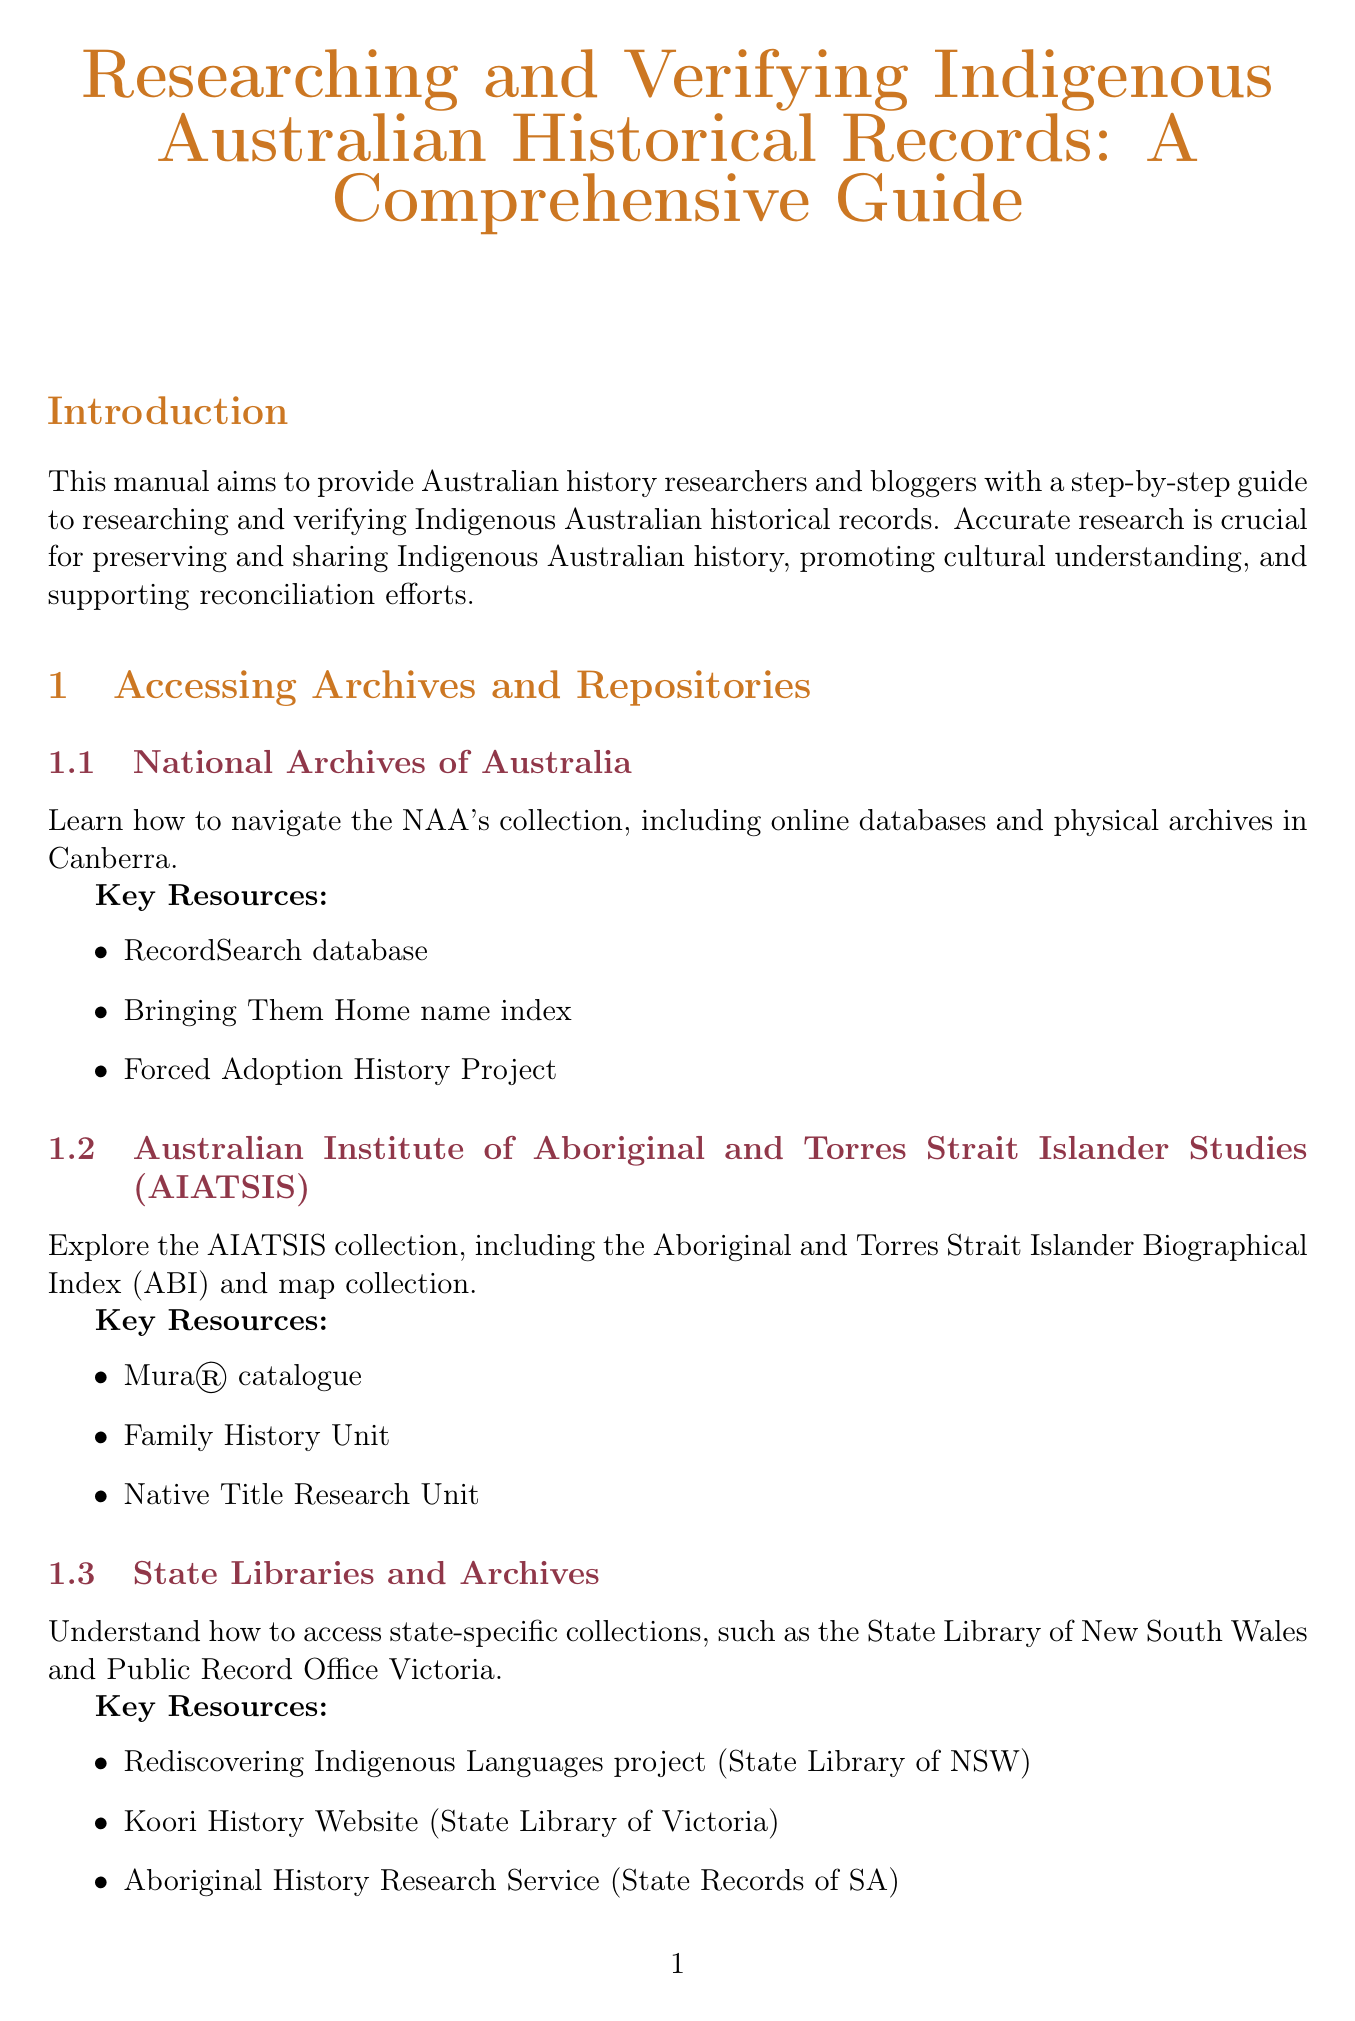What is the title of the manual? The title of the manual is stated at the beginning of the document.
Answer: Researching and Verifying Indigenous Australian Historical Records: A Comprehensive Guide How many chapters are in the manual? The manual lists five main chapters, each covering different topics related to research.
Answer: 5 What is the main purpose of this manual? The purpose is mentioned in the introduction section, outlining the aim of the manual.
Answer: To provide a step-by-step guide to researching and verifying Indigenous Australian historical records What key resource is listed under the National Archives of Australia? Key resources related to the National Archives are provided in the corresponding subsection.
Answer: RecordSearch database What are the ethical guidelines mentioned for using Indigenous knowledge? The document specifies guidelines that researchers should follow when using Indigenous cultural properties.
Answer: AIATSIS Guidelines for Ethical Research in Australian Indigenous Studies What is a strategy for effectively communicating research findings on social media? The manual suggests several strategies for writing on social media, including creating visually appealing elements.
Answer: Creating visually appealing infographics Which organization is mentioned as a key partner for verifying research findings? The document highlights several organizations; one is specified in the cross-referencing section.
Answer: Local Aboriginal Land Councils What is a key consideration when addressing sensitive topics? Important considerations are provided in the relevant section of the manual.
Answer: Using appropriate terminology and language 